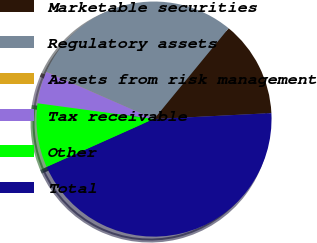Convert chart to OTSL. <chart><loc_0><loc_0><loc_500><loc_500><pie_chart><fcel>Marketable securities<fcel>Regulatory assets<fcel>Assets from risk management<fcel>Tax receivable<fcel>Other<fcel>Total<nl><fcel>13.25%<fcel>29.34%<fcel>0.03%<fcel>4.43%<fcel>8.84%<fcel>44.11%<nl></chart> 